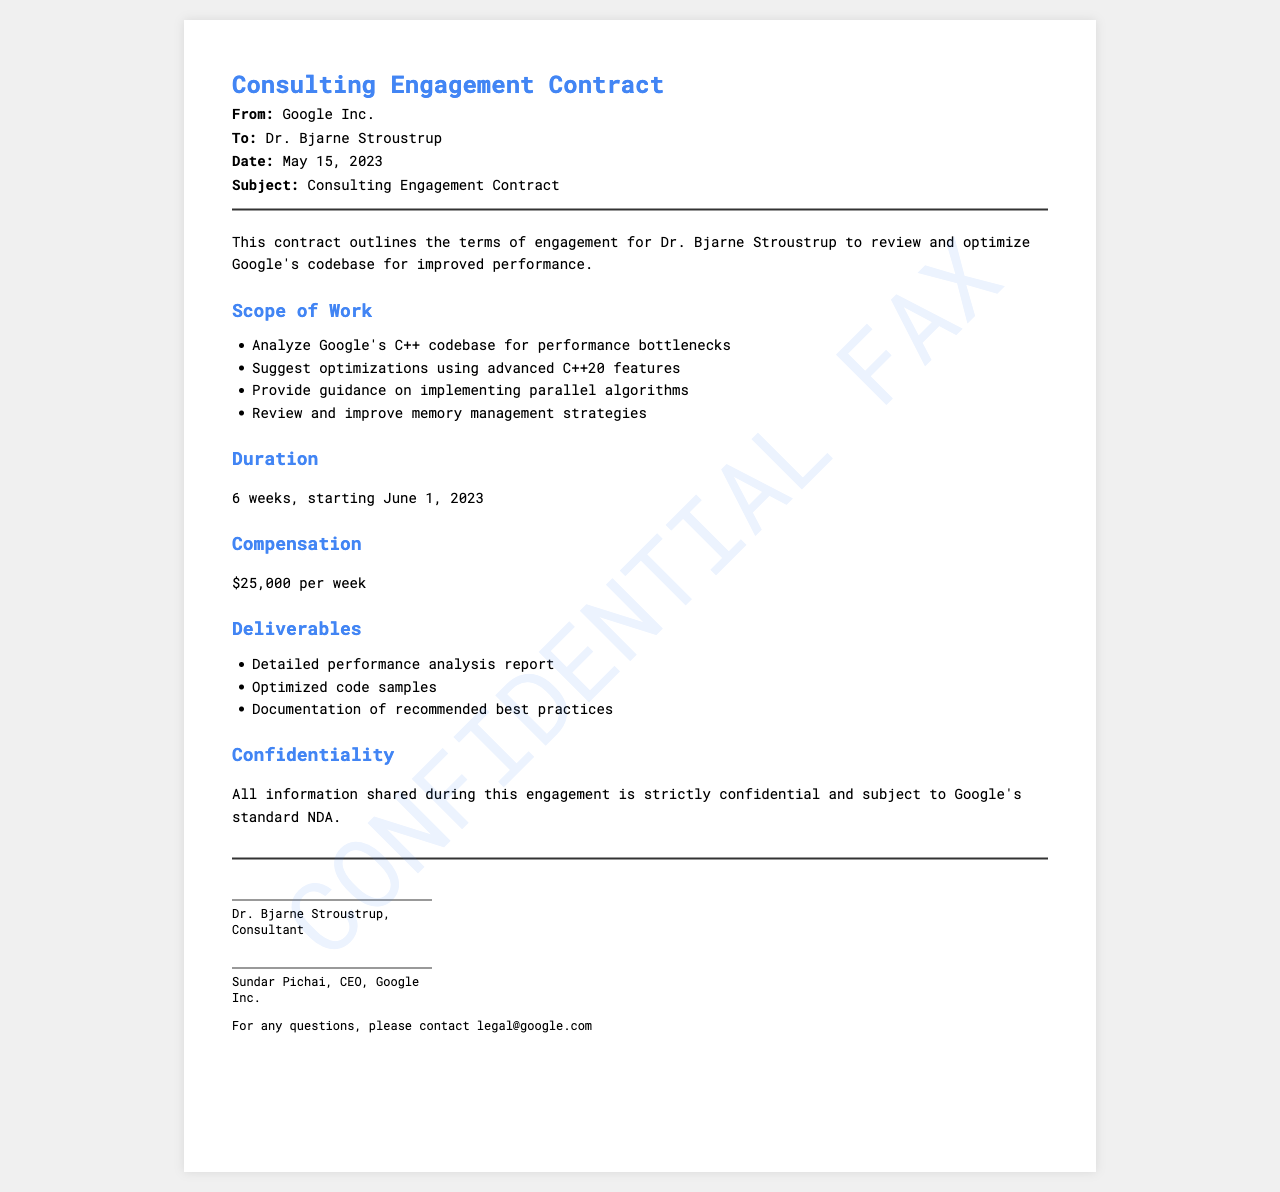What is the name of the consulting recipient? The recipient of the consulting engagement is mentioned in the document as Dr. Bjarne Stroustrup.
Answer: Dr. Bjarne Stroustrup What is the duration of the engagement? The duration of the engagement, as stated in the document, is 6 weeks, starting June 1, 2023.
Answer: 6 weeks What is the weekly compensation for the consultant? The document specifies the compensation as $25,000 per week.
Answer: $25,000 What company is requesting the consulting engagement? The company that issued the contract is mentioned at the beginning of the document as Google Inc.
Answer: Google Inc What are the deliverables mentioned in the contract? The deliverables specified include a detailed performance analysis report, optimized code samples, and documentation of recommended best practices.
Answer: Detailed performance analysis report, optimized code samples, documentation of recommended best practices What is the subject of the fax? The subject of the fax is clearly stated in the document as Consulting Engagement Contract.
Answer: Consulting Engagement Contract Why is confidentiality emphasized in the document? Confidentiality is emphasized because all information shared during the engagement is subject to Google's standard NDA.
Answer: Standard NDA How many optimization suggestions will be provided? The document does not specify an exact number of optimization suggestions but mentions suggesting optimizations using advanced C++20 features.
Answer: Not specified Which algorithms will be reviewed as part of the scope of work? The scope of work mentions providing guidance on implementing parallel algorithms.
Answer: Parallel algorithms 